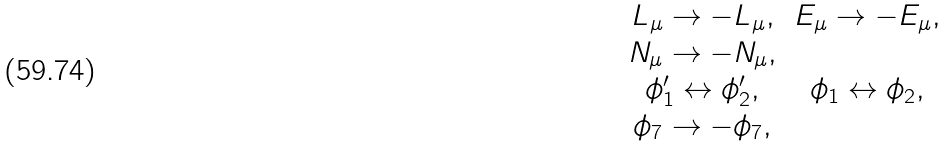Convert formula to latex. <formula><loc_0><loc_0><loc_500><loc_500>\begin{matrix} L _ { \mu } \rightarrow - L _ { \mu } , & E _ { \mu } \rightarrow - E _ { \mu } , \\ N _ { \mu } \rightarrow - N _ { \mu } , & \\ \phi _ { 1 } ^ { \prime } \leftrightarrow \phi _ { 2 } ^ { \prime } , & \phi _ { 1 } \leftrightarrow \phi _ { 2 } , \\ \phi _ { 7 } \rightarrow - \phi _ { 7 } , & \end{matrix}</formula> 